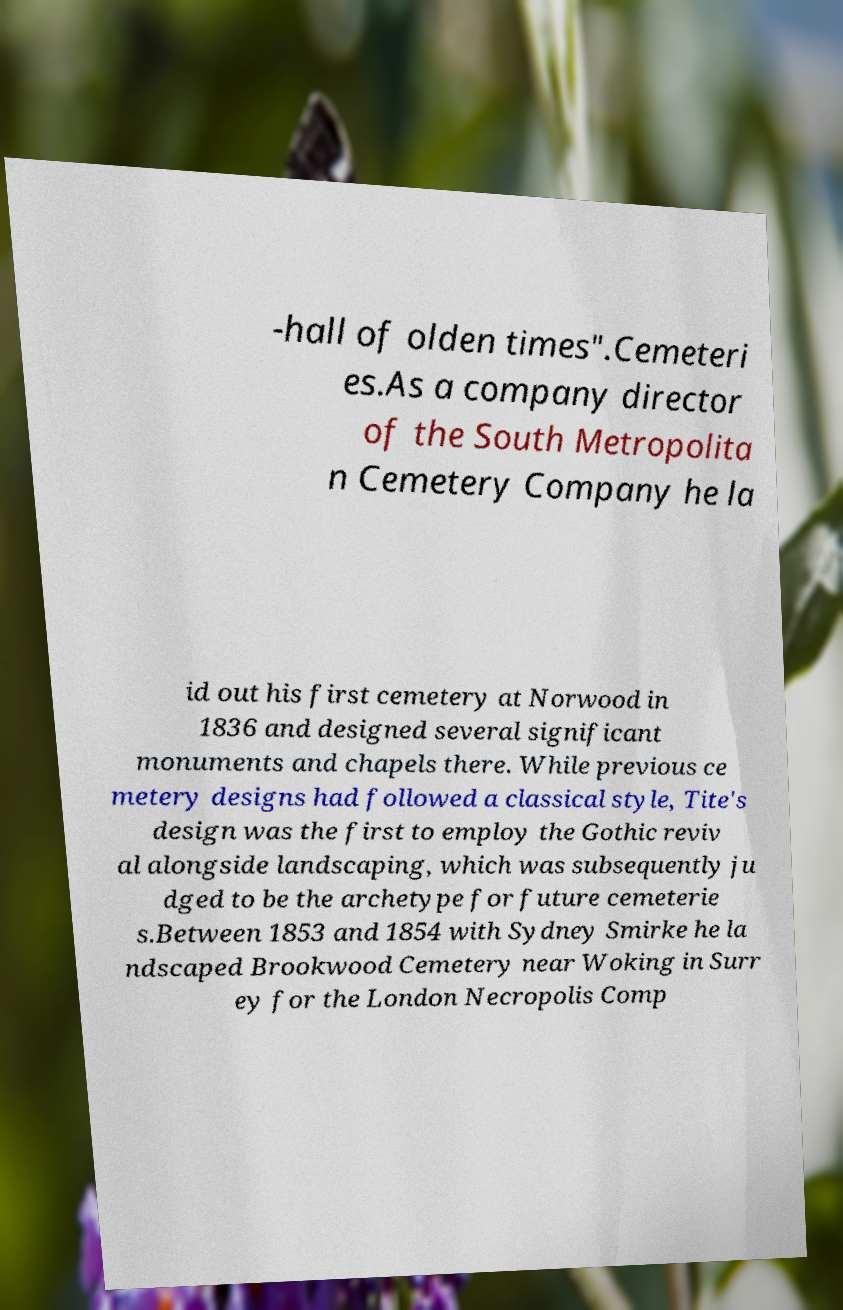What messages or text are displayed in this image? I need them in a readable, typed format. -hall of olden times".Cemeteri es.As a company director of the South Metropolita n Cemetery Company he la id out his first cemetery at Norwood in 1836 and designed several significant monuments and chapels there. While previous ce metery designs had followed a classical style, Tite's design was the first to employ the Gothic reviv al alongside landscaping, which was subsequently ju dged to be the archetype for future cemeterie s.Between 1853 and 1854 with Sydney Smirke he la ndscaped Brookwood Cemetery near Woking in Surr ey for the London Necropolis Comp 